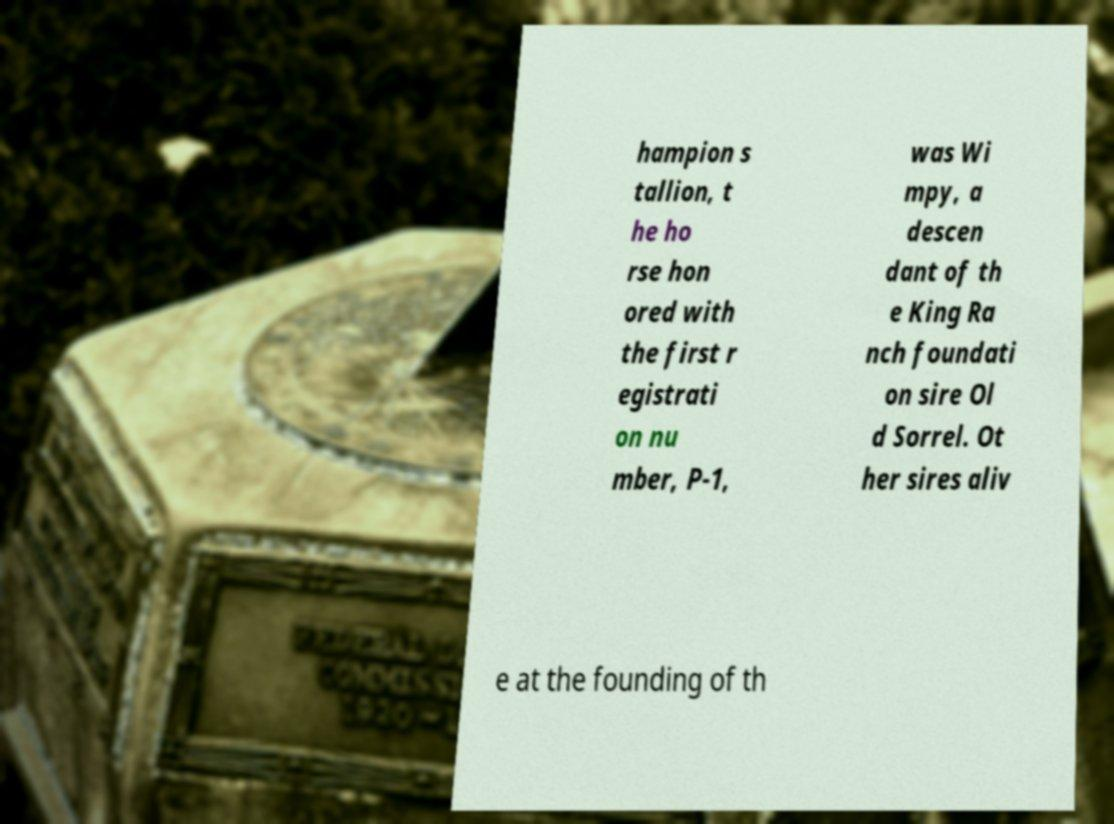There's text embedded in this image that I need extracted. Can you transcribe it verbatim? hampion s tallion, t he ho rse hon ored with the first r egistrati on nu mber, P-1, was Wi mpy, a descen dant of th e King Ra nch foundati on sire Ol d Sorrel. Ot her sires aliv e at the founding of th 